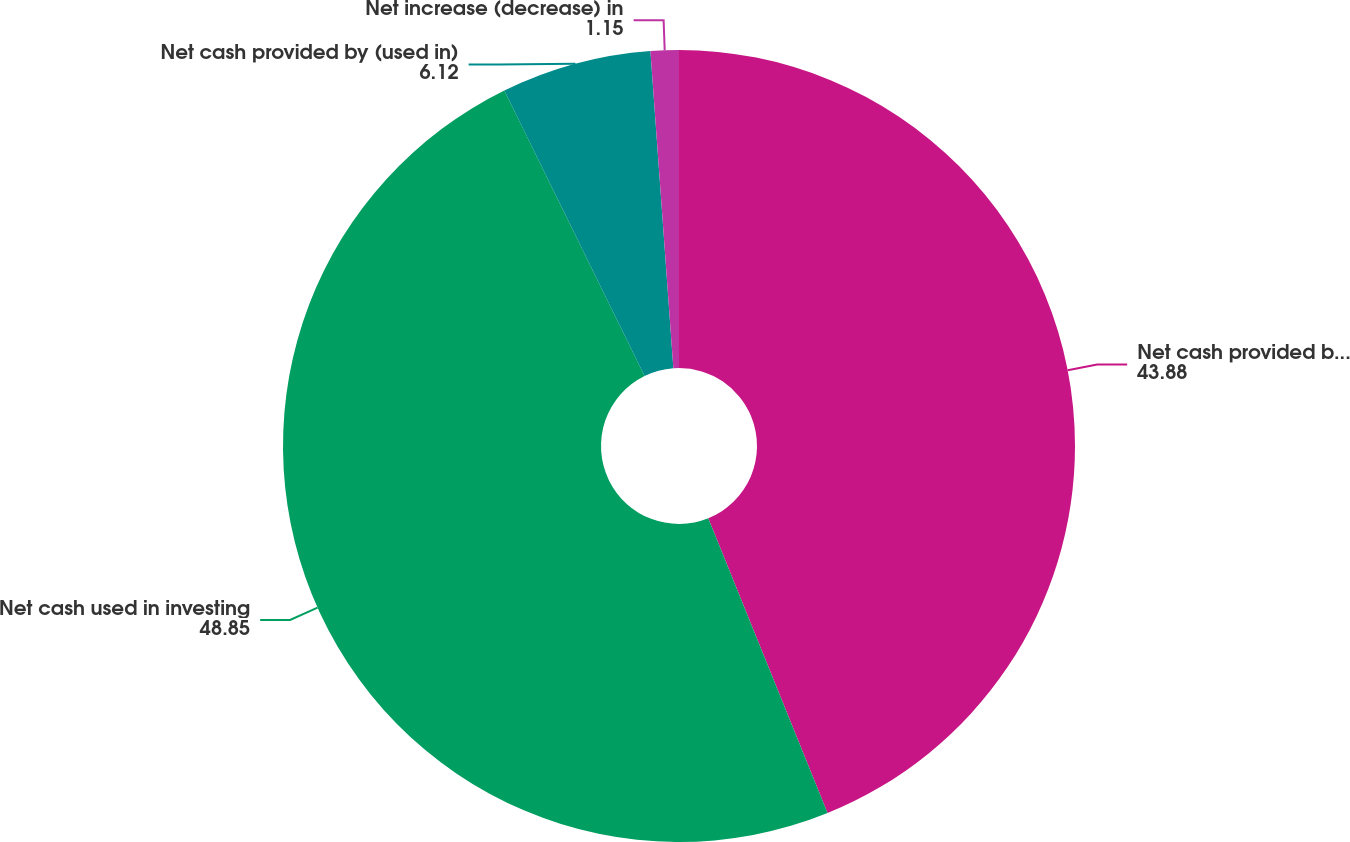Convert chart to OTSL. <chart><loc_0><loc_0><loc_500><loc_500><pie_chart><fcel>Net cash provided by operating<fcel>Net cash used in investing<fcel>Net cash provided by (used in)<fcel>Net increase (decrease) in<nl><fcel>43.88%<fcel>48.85%<fcel>6.12%<fcel>1.15%<nl></chart> 